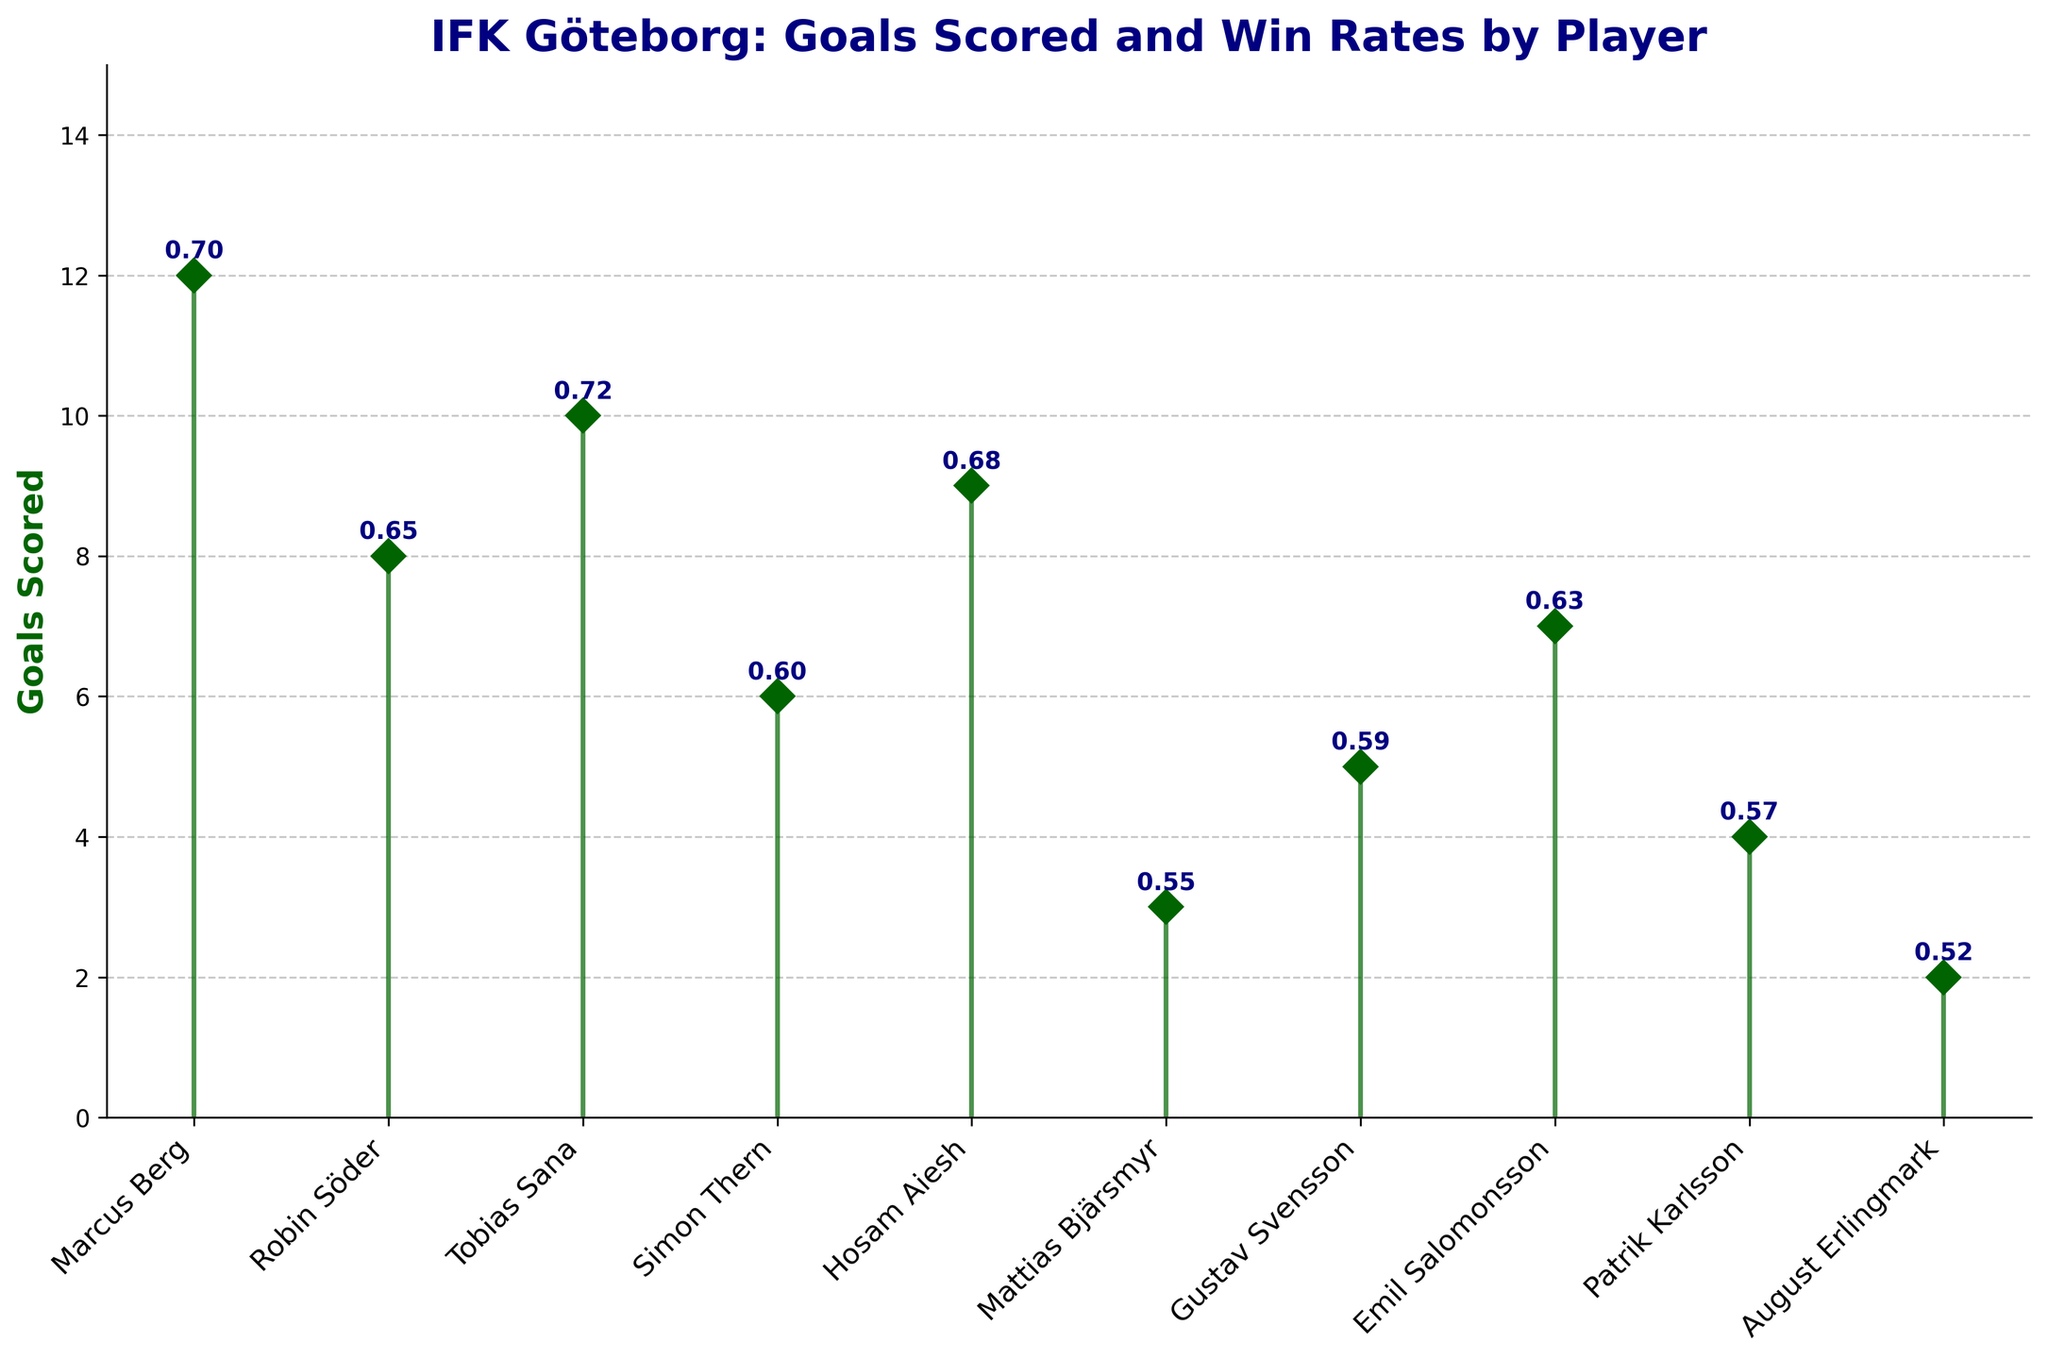What's the title of the figure? The title is usually located at the top of the figure in a larger, bolded font. In the given information, the title is explicitly mentioned.
Answer: IFK Göteborg: Goals Scored and Win Rates by Player What is the color of the stem lines? The stem lines are described in the code and usually are displayed in a noticeable, darker color in comparison to the marker line. In this case, it's mentioned as 'darkgreen'.
Answer: Dark green How many goals did Marcus Berg score? To find this information, look at the marker line directly above Marcus Berg's name. The annotated text shows the number of goals scored by him.
Answer: 12 What is the win rate for Tobias Sana? The win rate for each player is annotated next to their respective marker on the figure. Locate Tobias Sana's position and read the annotation.
Answer: 0.72 Which player scored the fewest goals and how many? The figure lists the players with corresponding goals. The lowest marker line represents the player with the fewest goals.
Answer: August Erlingmark with 2 goals How many players have a win rate of higher than 0.6? To answer this, look at the annotated win rates next to each marker and count how many are above 0.60. There are 6 players with win rates above 0.60: Marcus Berg, Robin Söder, Tobias Sana, Hosam Aiesh, Emil Salomonsson, and Simon Thern.
Answer: 6 What’s the difference in win rate between Marcus Berg and Hosam Aiesh? Check the annotated win rates for Marcus Berg (0.70) and Hosam Aiesh (0.68) and subtract the values.
Answer: 0.02 Who has a higher win rate: Robin Söder or Gustav Svensson? Compare the annotated win rates next to the names Robin Söder (0.65) and Gustav Svensson (0.59).
Answer: Robin Söder Which player with less than 5 goals has the highest win rate? From the figure, identify the players who scored less than 5 goals and compare their win rates. These players are Mattias Bjärsmyr, Patrik Karlsson, and August Erlingmark, with Mattias Bjärsmyr having the highest win rate (0.55).
Answer: Mattias Bjärsmyr What's the total number of goals scored by players with win rates above 0.65? First, identify the players with win rates above 0.65: Marcus Berg, Tobias Sana, and Hosam Aiesh. Then sum their goals scored: 12 + 10 + 9.
Answer: 31 